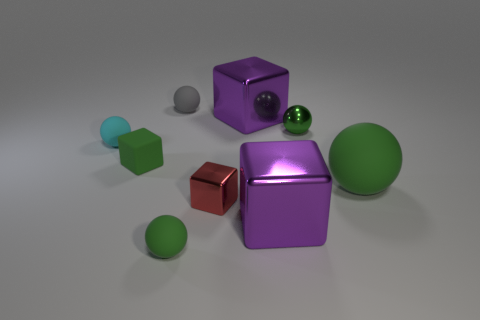Subtract all yellow cylinders. How many green balls are left? 3 Subtract all gray balls. How many balls are left? 4 Subtract 2 spheres. How many spheres are left? 3 Subtract all small shiny balls. How many balls are left? 4 Subtract all blue balls. Subtract all green cylinders. How many balls are left? 5 Subtract all cubes. How many objects are left? 5 Add 9 small cyan matte things. How many small cyan matte things are left? 10 Add 4 small red objects. How many small red objects exist? 5 Subtract 0 blue cylinders. How many objects are left? 9 Subtract all big metal spheres. Subtract all metallic cubes. How many objects are left? 6 